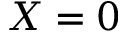<formula> <loc_0><loc_0><loc_500><loc_500>X = 0</formula> 